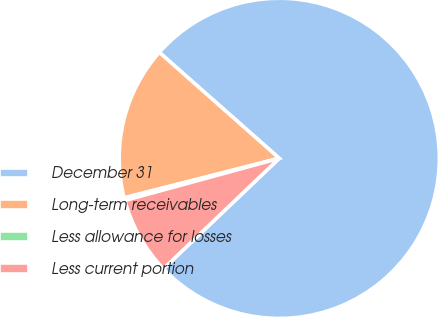Convert chart. <chart><loc_0><loc_0><loc_500><loc_500><pie_chart><fcel>December 31<fcel>Long-term receivables<fcel>Less allowance for losses<fcel>Less current portion<nl><fcel>76.37%<fcel>15.49%<fcel>0.27%<fcel>7.88%<nl></chart> 